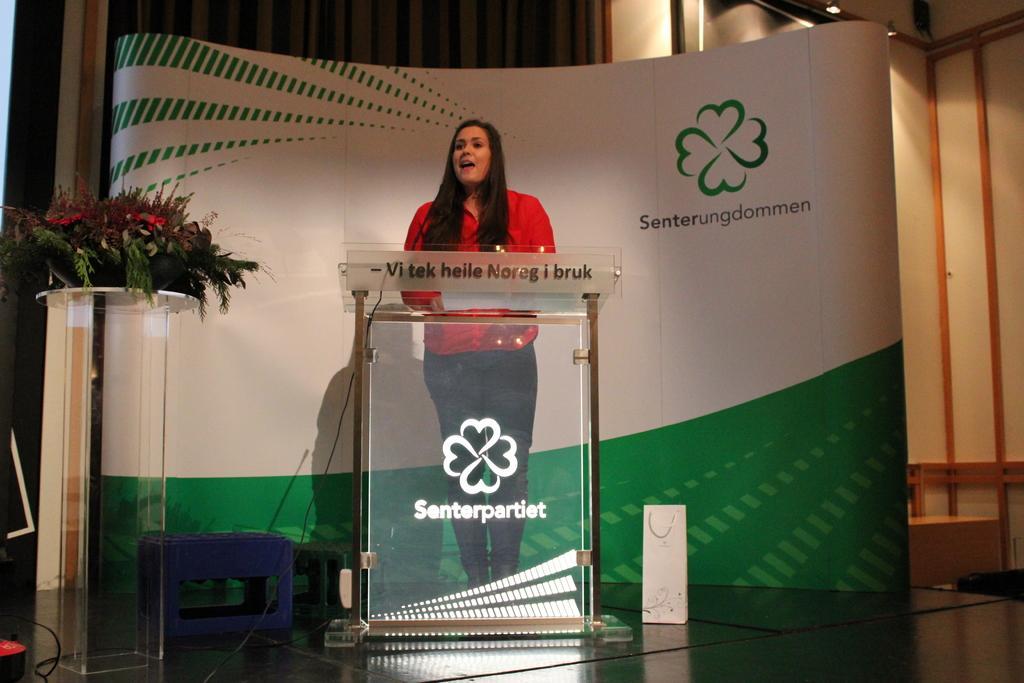How would you summarize this image in a sentence or two? In this image, we can see a woman is standing behind the glass podium and talking. Background we can see banner, curtains and wall. Left side of the image, we can see stools, stand with flower bouquet. At the bottom, we can see the stage and carry bag. 